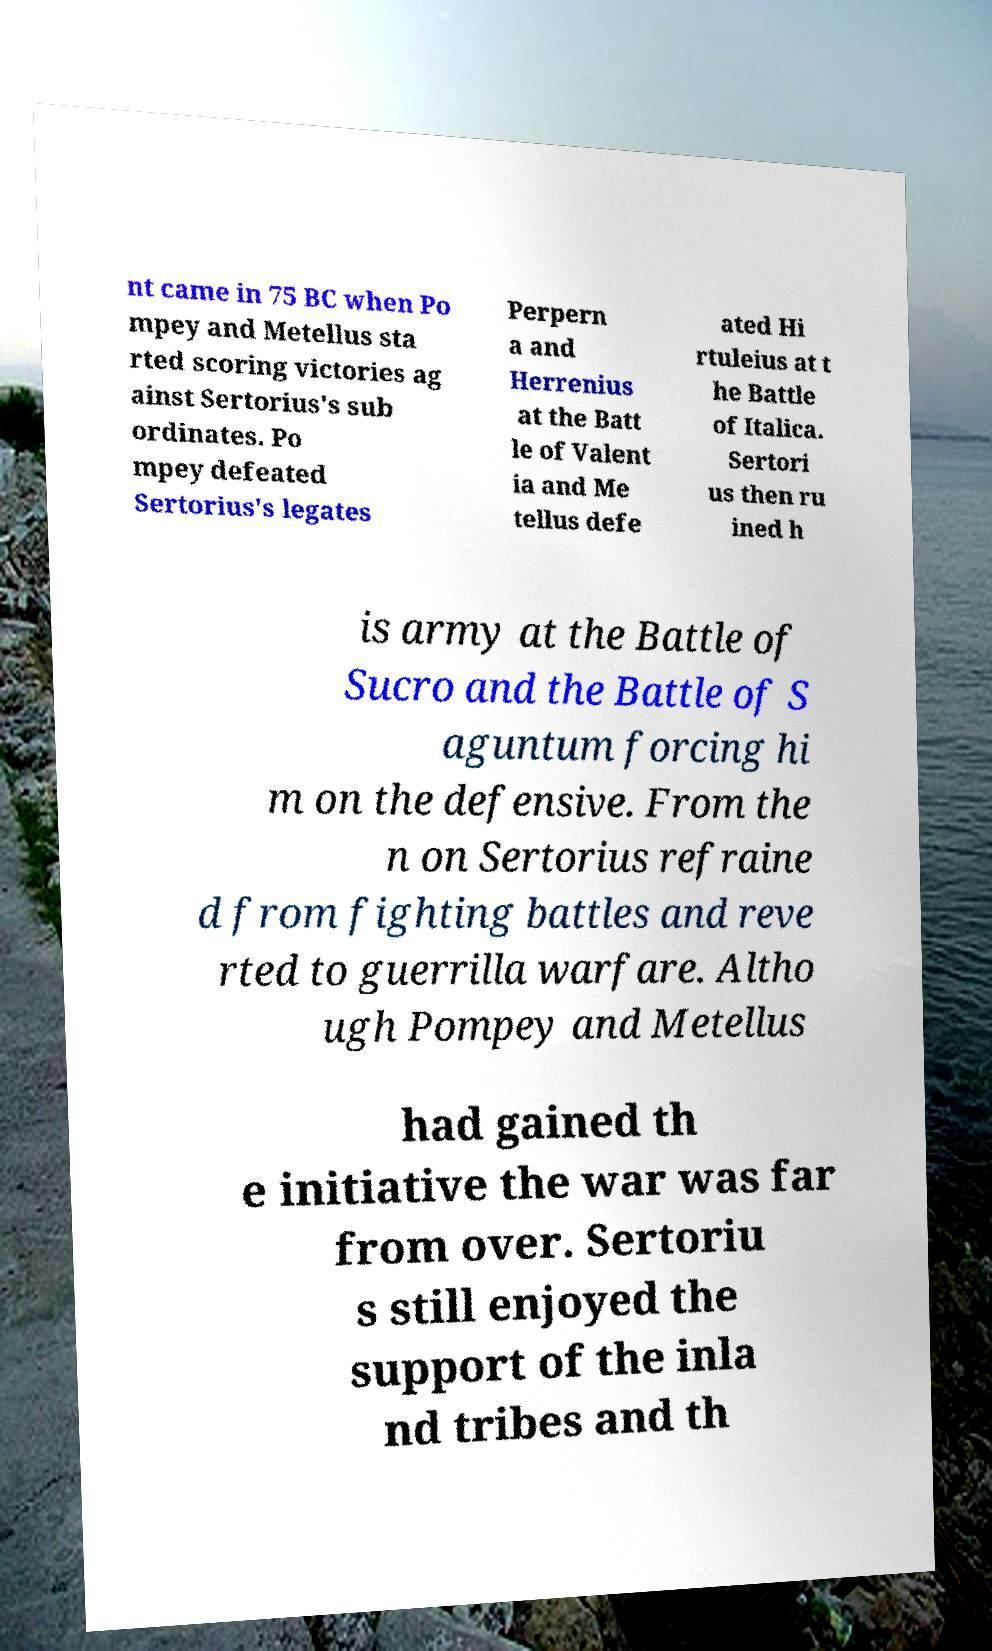Please read and relay the text visible in this image. What does it say? nt came in 75 BC when Po mpey and Metellus sta rted scoring victories ag ainst Sertorius's sub ordinates. Po mpey defeated Sertorius's legates Perpern a and Herrenius at the Batt le of Valent ia and Me tellus defe ated Hi rtuleius at t he Battle of Italica. Sertori us then ru ined h is army at the Battle of Sucro and the Battle of S aguntum forcing hi m on the defensive. From the n on Sertorius refraine d from fighting battles and reve rted to guerrilla warfare. Altho ugh Pompey and Metellus had gained th e initiative the war was far from over. Sertoriu s still enjoyed the support of the inla nd tribes and th 